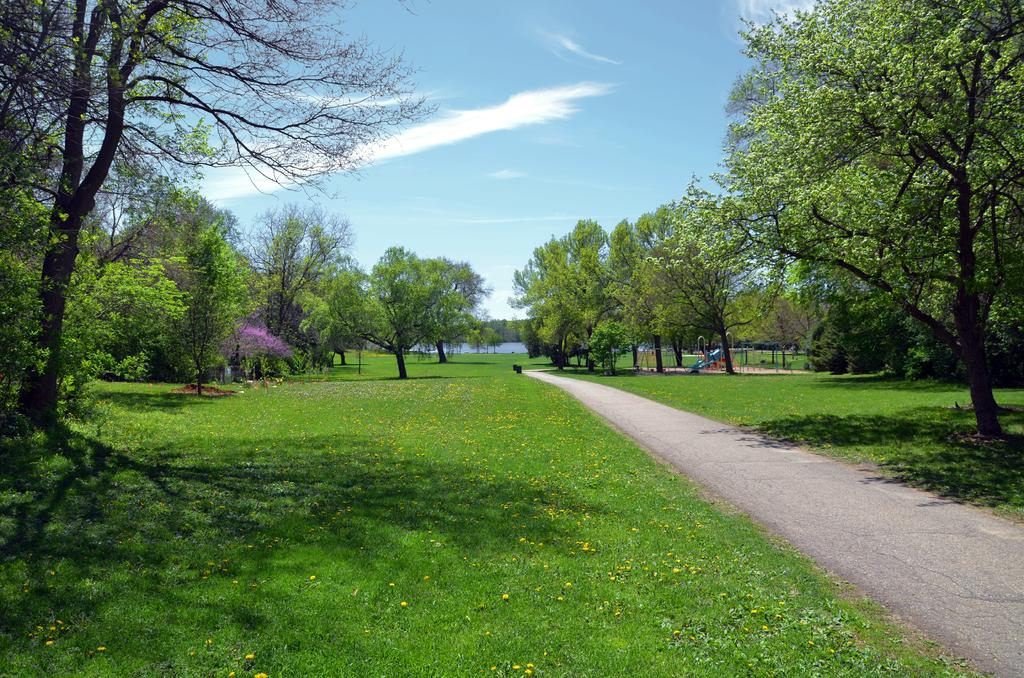What type of vegetation can be seen in the image? There are trees, plants, and grass visible in the image. What is the primary feature of the play area in the image? The play area in the image is not described in detail, so we cannot determine its primary feature. What is the condition of the sky in the image? The sky is visible in the image. Can the water be seen in the image? Yes, water is visible in the image. What type of corn can be seen growing in the image? There is no corn present in the image. What type of metal is used to construct the play area in the image? The play area in the image is not described in detail, so we cannot determine the type of metal used in its construction. --- Facts: 1. There is a person in the image. 2. The person is wearing a hat. 3. The person is holding a book. 4. There is a table in the image. 5. The table has a lamp on it. Absurd Topics: elephant, ocean, high Conversation: What is the person in the image doing? The person in the image is holding a book. What accessory is the person wearing in the image? The person is wearing a hat. What is on the table in the image? The table has a lamp on it. Reasoning: Let's think step by step in order to produce the conversation. We start by identifying the main subject in the image, which is the person holding a book. Then, we expand the conversation to include other items that are also visible, such as the hat worn by the person and the lamp on the table. Each question is designed to elicit a specific detail about the image that is known from the provided facts. Absurd Question/Answer: Can you see an elephant swimming in the ocean in the image? There is no elephant or ocean present in the image. How high is the person standing on the table in the image? The person is not standing on the table in the image; they are holding a book. 